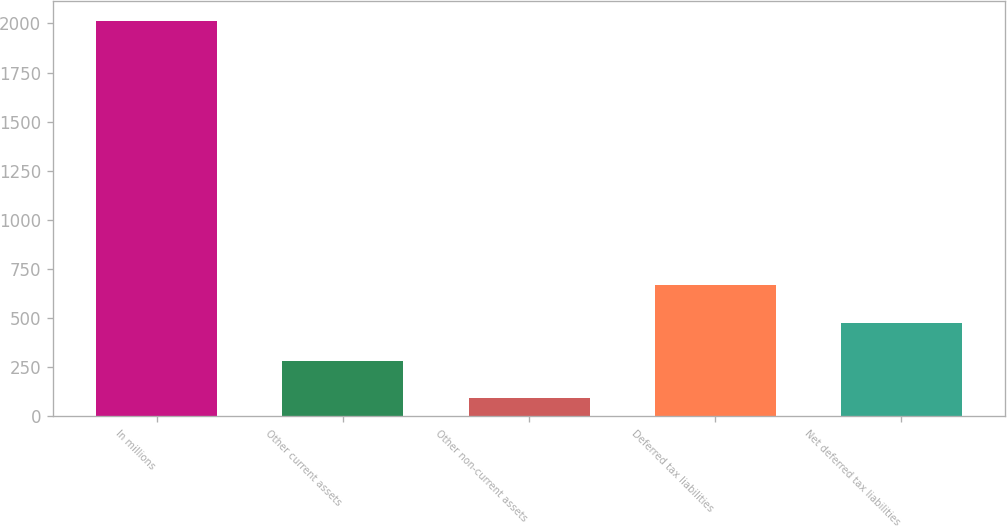Convert chart to OTSL. <chart><loc_0><loc_0><loc_500><loc_500><bar_chart><fcel>In millions<fcel>Other current assets<fcel>Other non-current assets<fcel>Deferred tax liabilities<fcel>Net deferred tax liabilities<nl><fcel>2013<fcel>284.46<fcel>92.4<fcel>668.58<fcel>476.52<nl></chart> 